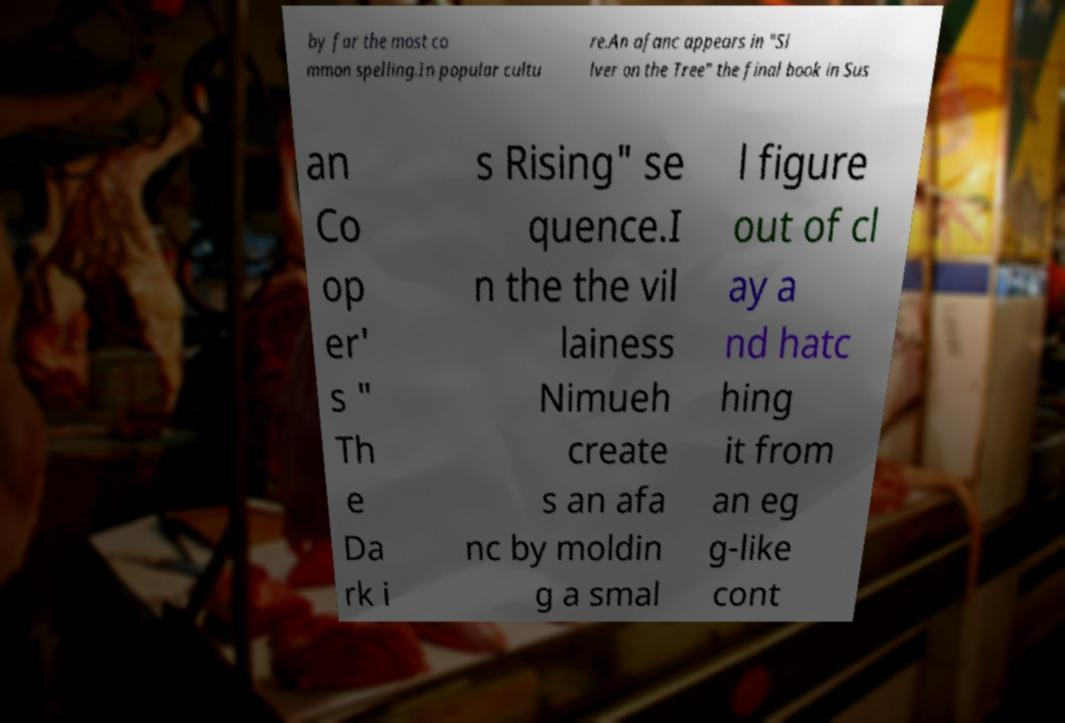Can you accurately transcribe the text from the provided image for me? by far the most co mmon spelling.In popular cultu re.An afanc appears in "Si lver on the Tree" the final book in Sus an Co op er' s " Th e Da rk i s Rising" se quence.I n the the vil lainess Nimueh create s an afa nc by moldin g a smal l figure out of cl ay a nd hatc hing it from an eg g-like cont 